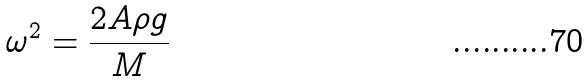<formula> <loc_0><loc_0><loc_500><loc_500>\omega ^ { 2 } = \frac { 2 A \rho g } { M }</formula> 